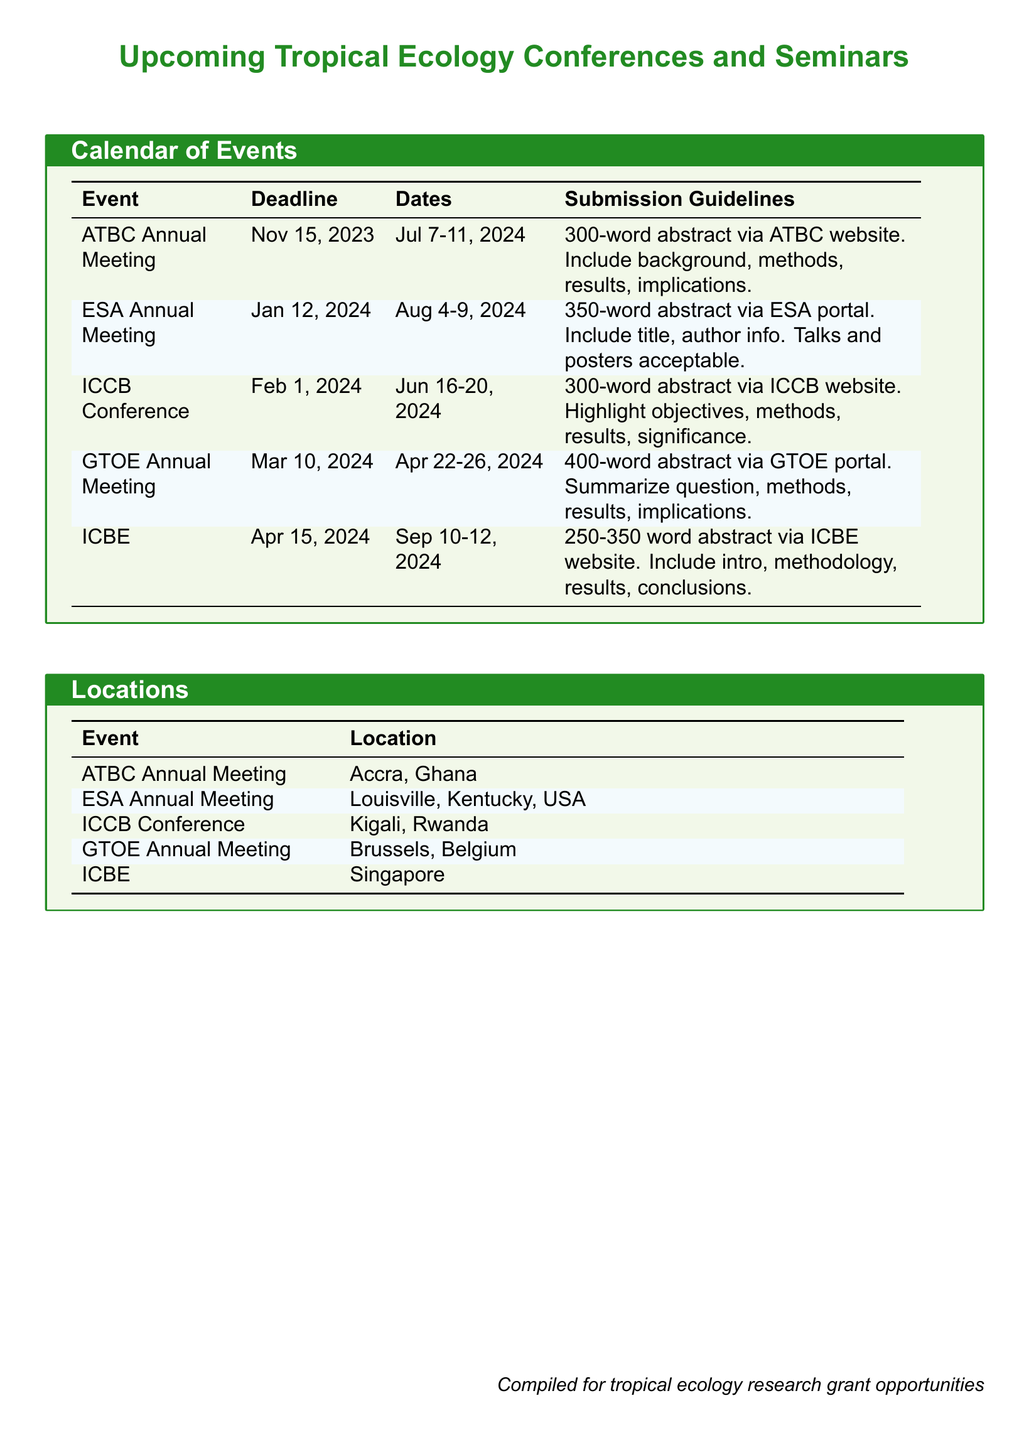What is the deadline for the ATBC Annual Meeting? The deadline for the ATBC Annual Meeting is stated clearly in the document as November 15, 2023.
Answer: November 15, 2023 Where will the ICCB Conference take place? The location for the ICCB Conference is provided in the document, which states it will take place in Kigali, Rwanda.
Answer: Kigali, Rwanda What is the word limit for abstracts submitted to the GTOE Annual Meeting? The document specifies that the word limit for abstracts for the GTOE Annual Meeting is 400 words.
Answer: 400 words What are the dates for the ESA Annual Meeting? The document mentions the dates for the ESA Annual Meeting as August 4-9, 2024.
Answer: August 4-9, 2024 How many events are listed in the calendar? The total number of events in the calendar is counted from the list provided, which shows five different events.
Answer: Five What is required in the abstract for the ICCB Conference? The submission guidelines for the ICCB Conference specify what needs to be included in the abstract, highlighting objectives, methods, results, and significance.
Answer: Objectives, methods, results, significance What type of presentation formats are acceptable for the ESA Annual Meeting? The document indicates that both talks and posters are acceptable formats for presentations at the ESA Annual Meeting.
Answer: Talks and posters What is the location of the ICBE conference? The document provides the location of the ICBE conference, which is in Singapore.
Answer: Singapore 